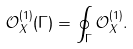<formula> <loc_0><loc_0><loc_500><loc_500>\mathcal { O } ^ { ( 1 ) } _ { X } ( \Gamma ) = \oint _ { \Gamma } \mathcal { O } ^ { ( 1 ) } _ { X } .</formula> 